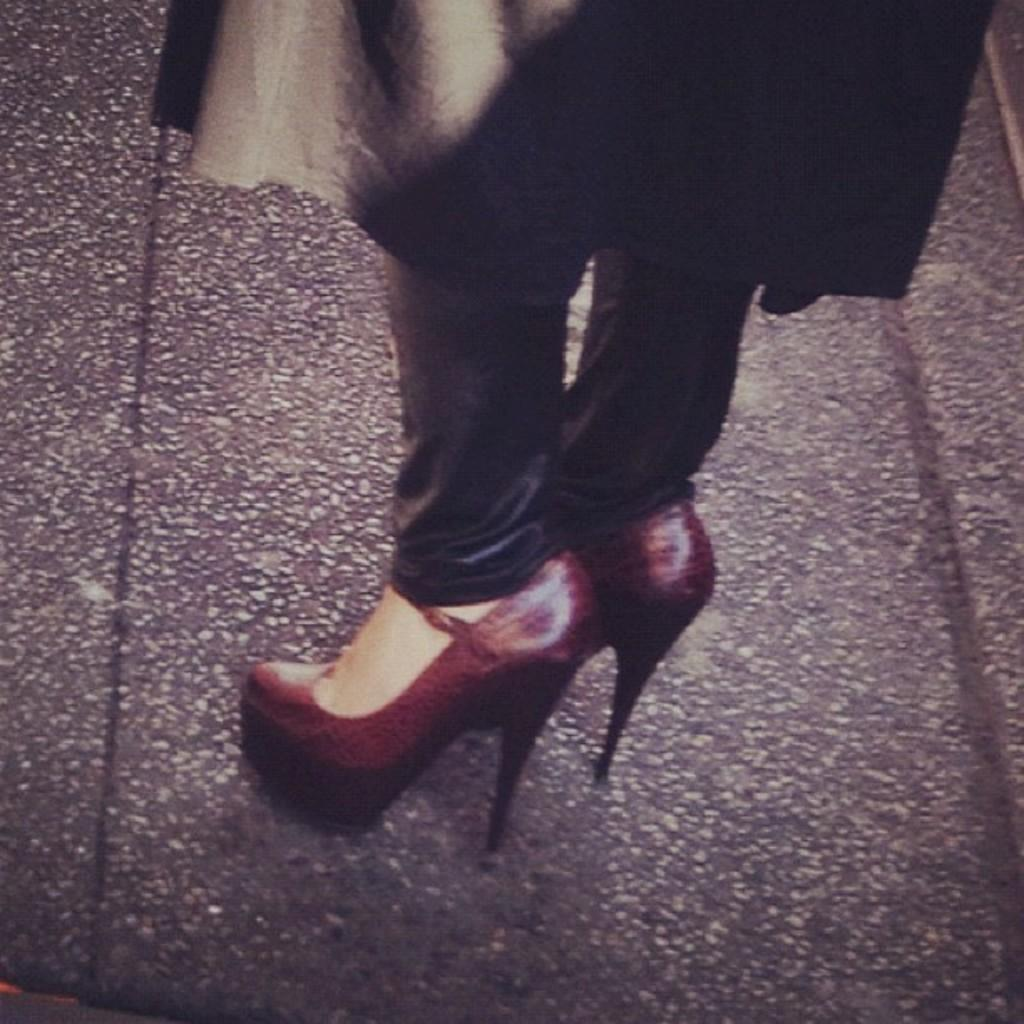What is present in the image? There is a person in the image. What part of the person's body can be seen? The person's legs are visible. What type of footwear is the person wearing? The person is wearing high heels. Where is the person standing? The person is standing on the road. What color is the dress the person is wearing? The person is wearing a black color dress. What type of cattle can be seen grazing in the image? There is no cattle present in the image; it features a person standing on the road. Is there any oil visible in the image? There is no oil present in the image. 